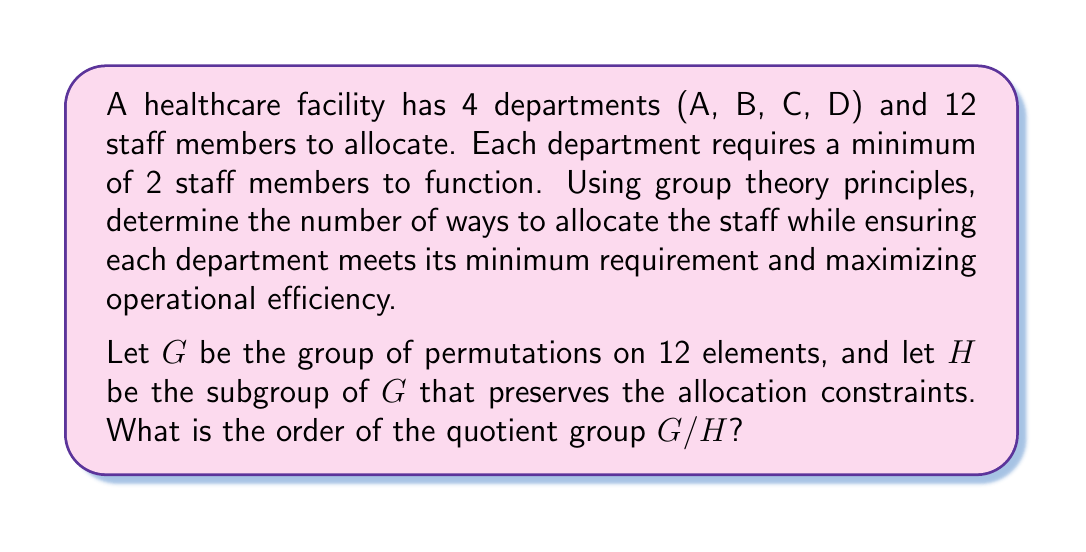Provide a solution to this math problem. To solve this problem, we'll use the following steps:

1) First, we need to determine the minimum allocation:
   Department A: 2 staff
   Department B: 2 staff
   Department C: 2 staff
   Department D: 2 staff
   Total minimum: 8 staff

2) This leaves 4 staff members to be allocated freely among the departments.

3) The problem can be modeled as distributing 4 indistinguishable objects (remaining staff) into 4 distinguishable boxes (departments). This is equivalent to finding the number of ways to write 4 as an ordered sum of 4 non-negative integers.

4) This is a classic stars and bars problem. The number of ways to distribute $n$ indistinguishable objects into $k$ distinguishable boxes is given by the formula:

   $$\binom{n+k-1}{k-1} = \binom{n+k-1}{n}$$

5) In our case, $n = 4$ (remaining staff) and $k = 4$ (departments). So we have:

   $$\binom{4+4-1}{4-1} = \binom{7}{3} = 35$$

6) Now, for each of these 35 allocations, we need to consider the permutations of the 12 staff members. The total number of permutations is 12! = 479,001,600.

7) However, the order of staff within each department doesn't matter for our purposes. So for each allocation, we need to divide by the number of permutations within each department.

8) The order of $G$ (total permutations) is 12!

9) The order of $H$ (permutations that preserve the allocation) for a given allocation with $a$, $b$, $c$, and $d$ staff in each department is $a! * b! * c! * d!$

10) The order of $G/H$ is the number of distinct allocations, which is 35.

Therefore, the order of the quotient group $G/H$ is 35.
Answer: The order of the quotient group $G/H$ is 35. 